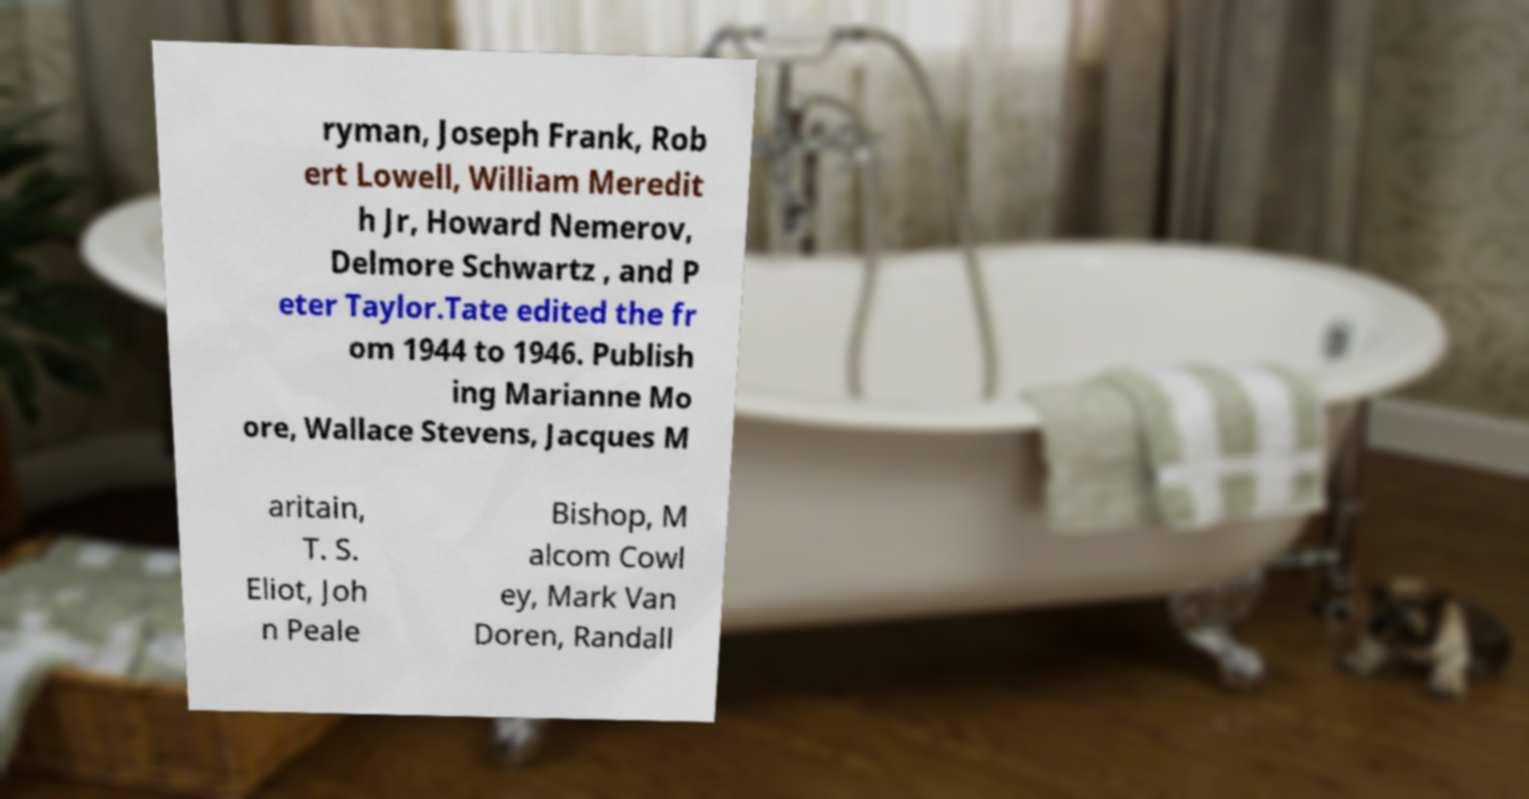What messages or text are displayed in this image? I need them in a readable, typed format. ryman, Joseph Frank, Rob ert Lowell, William Meredit h Jr, Howard Nemerov, Delmore Schwartz , and P eter Taylor.Tate edited the fr om 1944 to 1946. Publish ing Marianne Mo ore, Wallace Stevens, Jacques M aritain, T. S. Eliot, Joh n Peale Bishop, M alcom Cowl ey, Mark Van Doren, Randall 